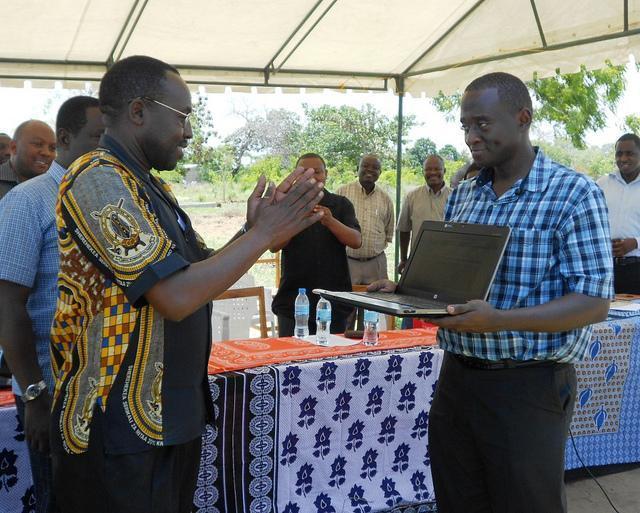How many women are in the image?
Give a very brief answer. 0. How many people are there?
Give a very brief answer. 8. How many of the airplanes have entrails?
Give a very brief answer. 0. 